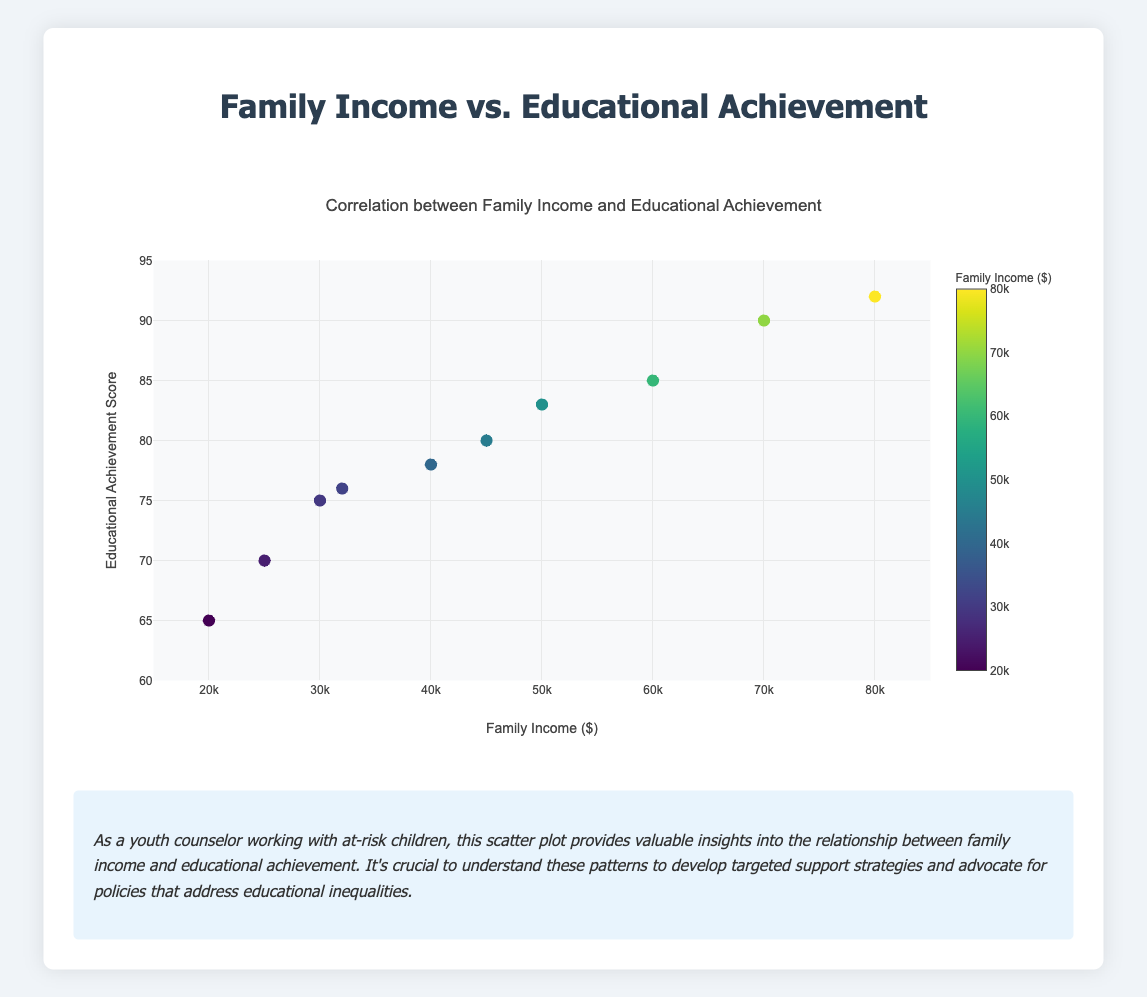What is the range of family income levels represented in the figure? The x-axis title indicates it represents Family Income in dollars. The minimum value on the x-axis appears to be 20,000, while the maximum value appears to be 80,000.
Answer: $20,000 to $80,000 Which axis represents educational achievement? By looking at the figure, the y-axis title is "Educational Achievement Score", which indicates that this axis represents the educational achievement.
Answer: Y-axis How many students have a family income below $35,000? Looking at the plots on the x-axis and counting the markers before $35,000, we see there are four markers corresponding to students with family income below this threshold.
Answer: 4 What is the highest educational achievement score shown in the plot? Observing the y-axis and the corresponding data points, the highest educational achievement score is 92.
Answer: 92 Compare the educational achievement of students with the lowest and highest family income. The student with the lowest family income ($20,000) has an educational achievement score of 65, while the student with the highest family income ($80,000) has an educational achievement score of 92. This indicates that the student with the highest family income achieved the higher educational score.
Answer: The student with the highest family income has a higher educational achievement What is the average educational achievement score for students with family incomes above $50,000? There are three students with family incomes above $50,000 (students with $60,000, $70,000, and $80,000). Their educational achievement scores are 85, 90, and 92. Averaging these scores: (85 + 90 + 92) / 3 = 89.
Answer: 89 Is there a general trend between family income and educational achievement? Observing the scatter plot, there appears to be a positive correlation where higher family income levels generally seem to be associated with higher educational achievement scores.
Answer: Positive correlation What is the family income for the student with an educational achievement score of 78? By locating the marker on the plot where the educational achievement score is 78 on the y-axis and tracing it horizontally to the x-axis, the family income corresponding to this student is $40,000.
Answer: $40,000 